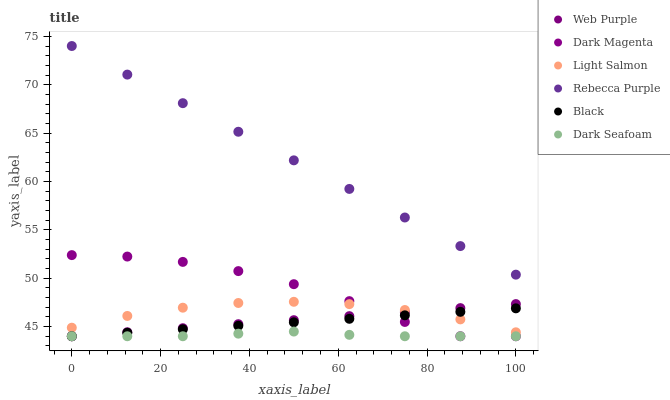Does Dark Seafoam have the minimum area under the curve?
Answer yes or no. Yes. Does Rebecca Purple have the maximum area under the curve?
Answer yes or no. Yes. Does Dark Magenta have the minimum area under the curve?
Answer yes or no. No. Does Dark Magenta have the maximum area under the curve?
Answer yes or no. No. Is Web Purple the smoothest?
Answer yes or no. Yes. Is Dark Magenta the roughest?
Answer yes or no. Yes. Is Dark Magenta the smoothest?
Answer yes or no. No. Is Web Purple the roughest?
Answer yes or no. No. Does Dark Magenta have the lowest value?
Answer yes or no. Yes. Does Rebecca Purple have the lowest value?
Answer yes or no. No. Does Rebecca Purple have the highest value?
Answer yes or no. Yes. Does Dark Magenta have the highest value?
Answer yes or no. No. Is Dark Magenta less than Rebecca Purple?
Answer yes or no. Yes. Is Rebecca Purple greater than Black?
Answer yes or no. Yes. Does Web Purple intersect Black?
Answer yes or no. Yes. Is Web Purple less than Black?
Answer yes or no. No. Is Web Purple greater than Black?
Answer yes or no. No. Does Dark Magenta intersect Rebecca Purple?
Answer yes or no. No. 